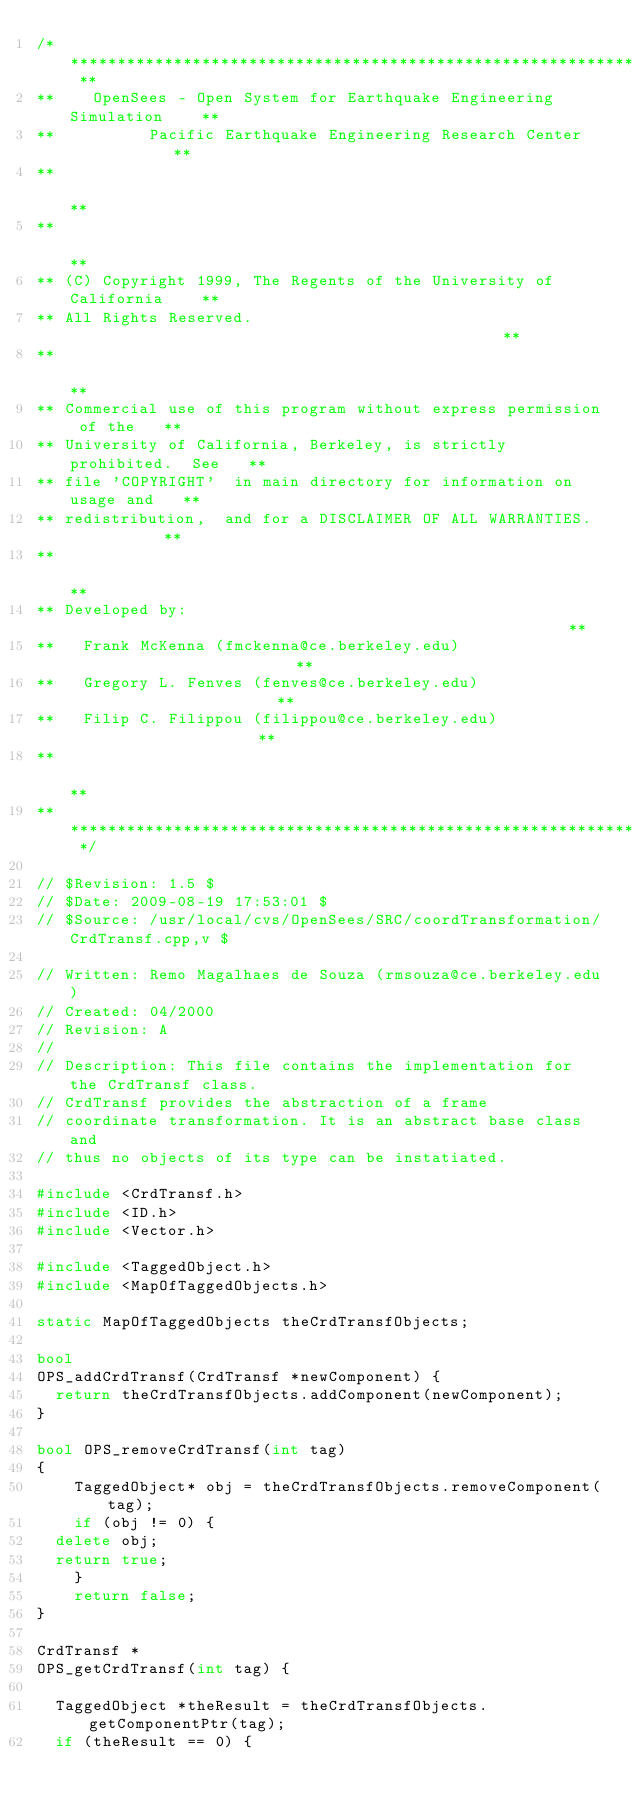<code> <loc_0><loc_0><loc_500><loc_500><_C++_>/* ****************************************************************** **
**    OpenSees - Open System for Earthquake Engineering Simulation    **
**          Pacific Earthquake Engineering Research Center            **
**                                                                    **
**                                                                    **
** (C) Copyright 1999, The Regents of the University of California    **
** All Rights Reserved.                                               **
**                                                                    **
** Commercial use of this program without express permission of the   **
** University of California, Berkeley, is strictly prohibited.  See   **
** file 'COPYRIGHT'  in main directory for information on usage and   **
** redistribution,  and for a DISCLAIMER OF ALL WARRANTIES.           **
**                                                                    **
** Developed by:                                                      **
**   Frank McKenna (fmckenna@ce.berkeley.edu)                         **
**   Gregory L. Fenves (fenves@ce.berkeley.edu)                       **
**   Filip C. Filippou (filippou@ce.berkeley.edu)                     **
**                                                                    **
** ****************************************************************** */

// $Revision: 1.5 $
// $Date: 2009-08-19 17:53:01 $
// $Source: /usr/local/cvs/OpenSees/SRC/coordTransformation/CrdTransf.cpp,v $

// Written: Remo Magalhaes de Souza (rmsouza@ce.berkeley.edu)
// Created: 04/2000
// Revision: A
//
// Description: This file contains the implementation for the CrdTransf class.
// CrdTransf provides the abstraction of a frame 
// coordinate transformation. It is an abstract base class and 
// thus no objects of its type can be instatiated. 

#include <CrdTransf.h>
#include <ID.h>
#include <Vector.h>

#include <TaggedObject.h>
#include <MapOfTaggedObjects.h>

static MapOfTaggedObjects theCrdTransfObjects;

bool 
OPS_addCrdTransf(CrdTransf *newComponent) {
  return theCrdTransfObjects.addComponent(newComponent);
}

bool OPS_removeCrdTransf(int tag)
{
    TaggedObject* obj = theCrdTransfObjects.removeComponent(tag);
    if (obj != 0) {
	delete obj;
	return true;
    }
    return false;
}

CrdTransf *
OPS_getCrdTransf(int tag) {

  TaggedObject *theResult = theCrdTransfObjects.getComponentPtr(tag);
  if (theResult == 0) {</code> 